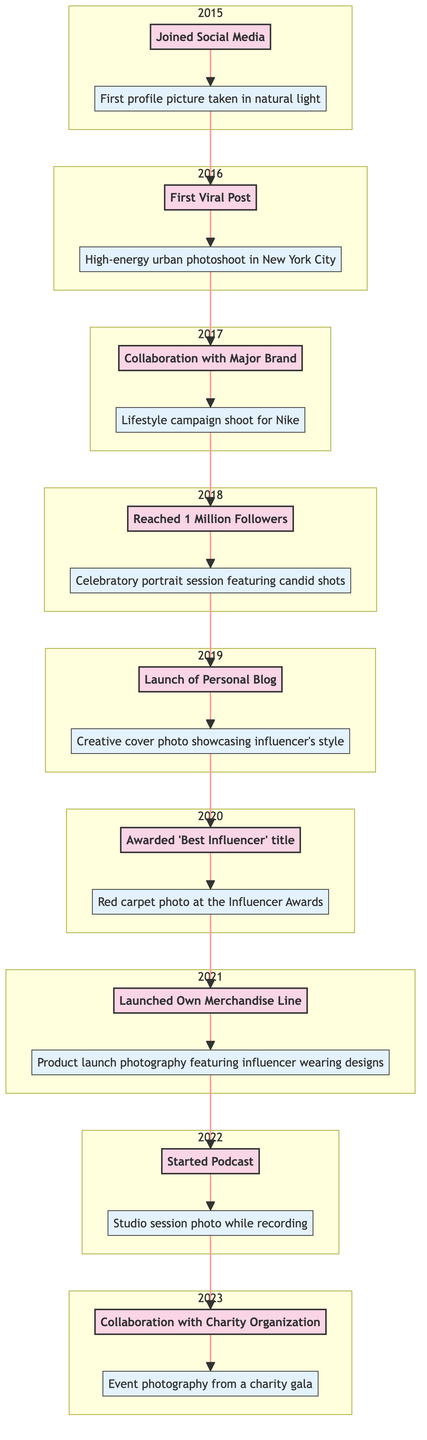What's the first milestone in the diagram? The first milestone can be found at the beginning of the flowchart, which is "Joined Social Media". It's the first node when following the arrows from left to right.
Answer: Joined Social Media How many milestones are there in the diagram? To determine the number of milestones, count the distinct "milestone" nodes in the diagram. There are a total of 9 milestones listed.
Answer: 9 What is the date of the milestone 'Reached 1 Million Followers'? Locate the milestone 'Reached 1 Million Followers' in the diagram and see its corresponding date, which is displayed nearby. The date given is "November 2018".
Answer: November 2018 What photograph corresponds to the milestone 'Collaboration with Major Brand'? Identify the milestone 'Collaboration with Major Brand' and then find the photograph that follows it in the diagram, which states "Lifestyle campaign shoot for Nike".
Answer: Lifestyle campaign shoot for Nike Which milestone directly follows 'First Viral Post'? By tracing the flow from 'First Viral Post', the next milestone that is connected directly is 'Collaboration with Major Brand'. This shows a sequential relationship in the diagram.
Answer: Collaboration with Major Brand What was the last milestone in the timeline? The last milestone can be found by following the flowchart to its end, which is 'Collaboration with Charity Organization'. It shows the progression towards the latest achievement.
Answer: Collaboration with Charity Organization Which photograph was taken for the 'Launch of Personal Blog' milestone? Check the pattern in the flowchart where the 'Launch of Personal Blog' milestone is located, and identify the photograph mentioned next to it. The corresponding photograph is "Creative cover photo showcasing influencer's style".
Answer: Creative cover photo showcasing influencer's style What significant event did the influencer achieve in February 2021? From the diagram, we can see that the milestone listed in February 2021 is 'Launched Own Merchandise Line', highlighting an important event in the influencer's career.
Answer: Launched Own Merchandise Line What photograph represents the milestone 'Awarded Best Influencer title'? Find the milestone 'Awarded Best Influencer title' in the flowchart and look for the related photograph provided, which is "Red carpet photo at the Influencer Awards".
Answer: Red carpet photo at the Influencer Awards 